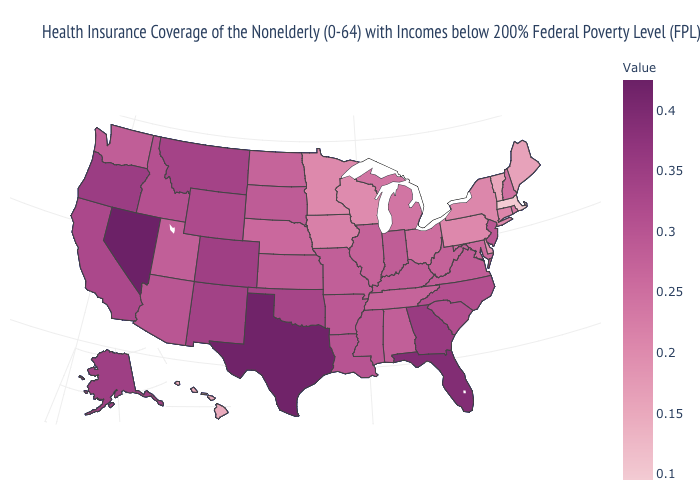Does New Hampshire have a higher value than Connecticut?
Write a very short answer. Yes. Which states hav the highest value in the Northeast?
Give a very brief answer. New Jersey. Does the map have missing data?
Be succinct. No. Which states have the highest value in the USA?
Be succinct. Nevada. Which states have the lowest value in the USA?
Answer briefly. Massachusetts. Does Alaska have a higher value than Utah?
Write a very short answer. Yes. Which states hav the highest value in the West?
Be succinct. Nevada. Is the legend a continuous bar?
Give a very brief answer. Yes. 